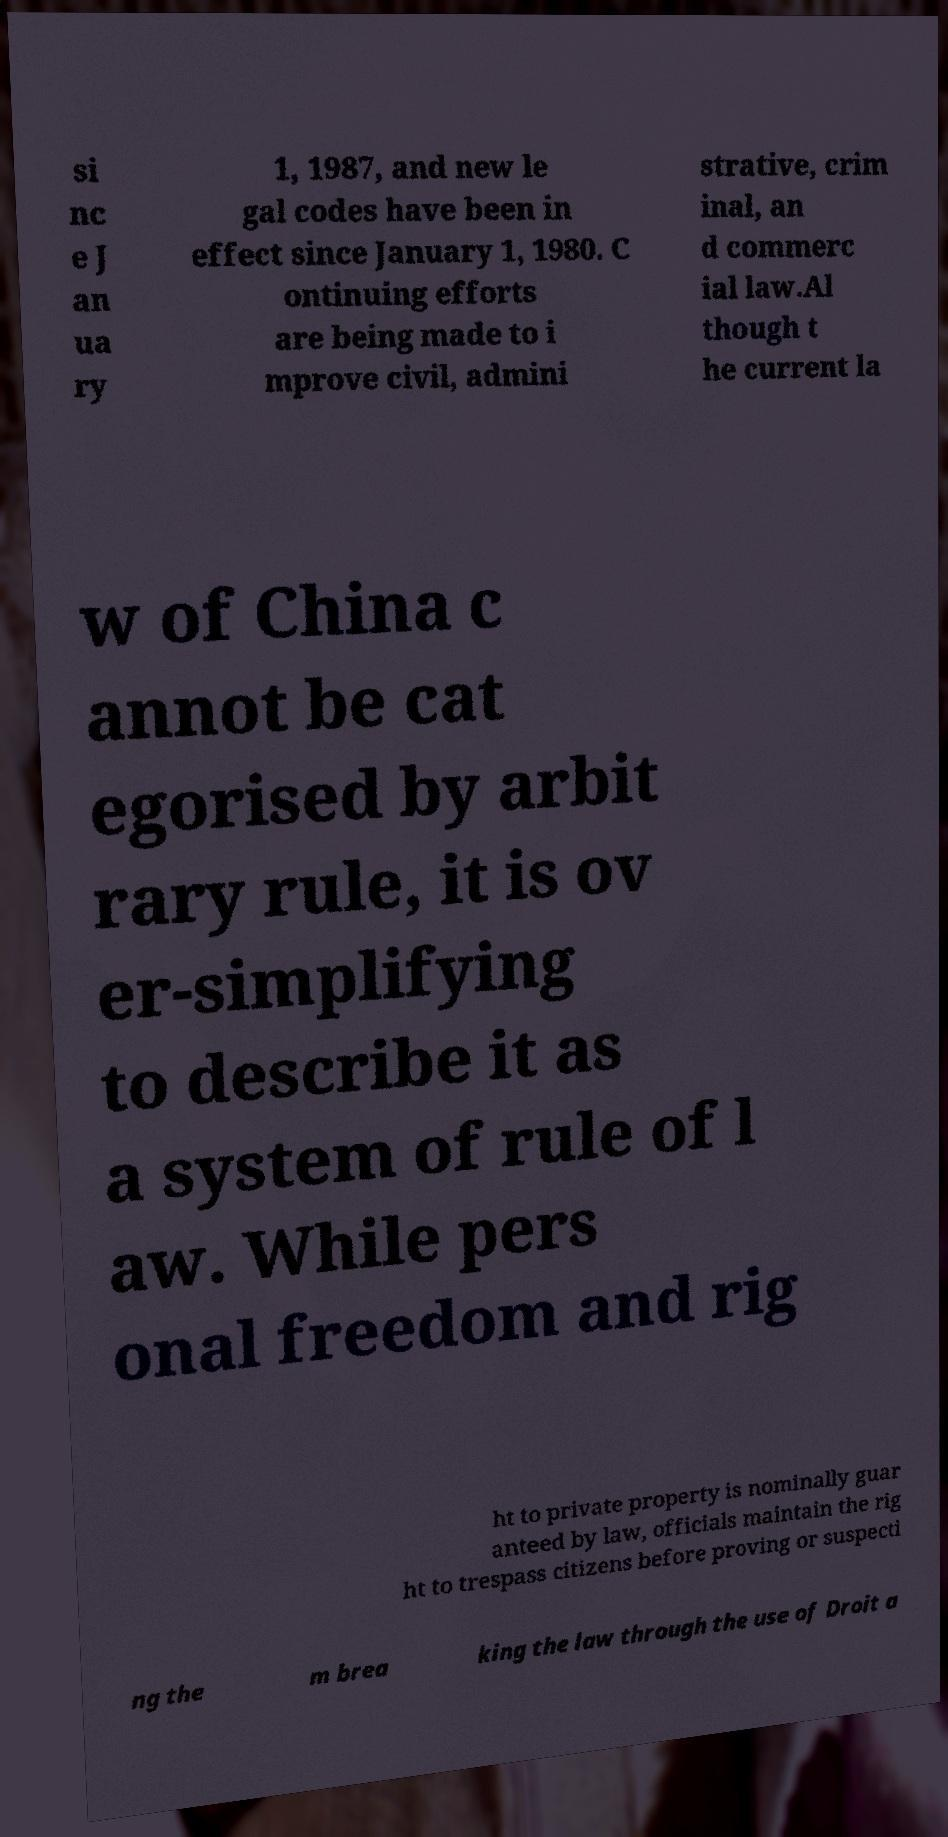Can you accurately transcribe the text from the provided image for me? si nc e J an ua ry 1, 1987, and new le gal codes have been in effect since January 1, 1980. C ontinuing efforts are being made to i mprove civil, admini strative, crim inal, an d commerc ial law.Al though t he current la w of China c annot be cat egorised by arbit rary rule, it is ov er-simplifying to describe it as a system of rule of l aw. While pers onal freedom and rig ht to private property is nominally guar anteed by law, officials maintain the rig ht to trespass citizens before proving or suspecti ng the m brea king the law through the use of Droit a 